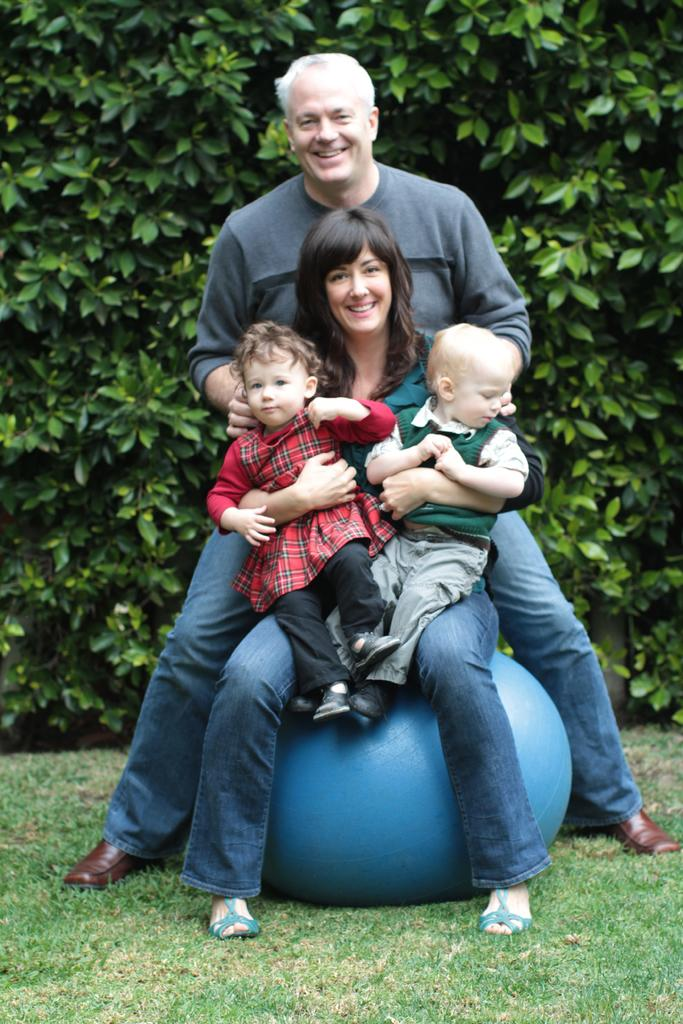Who is present in the image? There is a family in the image. What are they sitting on? The family is sitting on a bean bag. What can be seen in the background of the image? There are trees visible in the background of the image. Is there a beggar asking for money in the image? No, there is no beggar present in the image. What type of farm can be seen in the background of the image? There is no farm visible in the image; only trees are present in the background. 